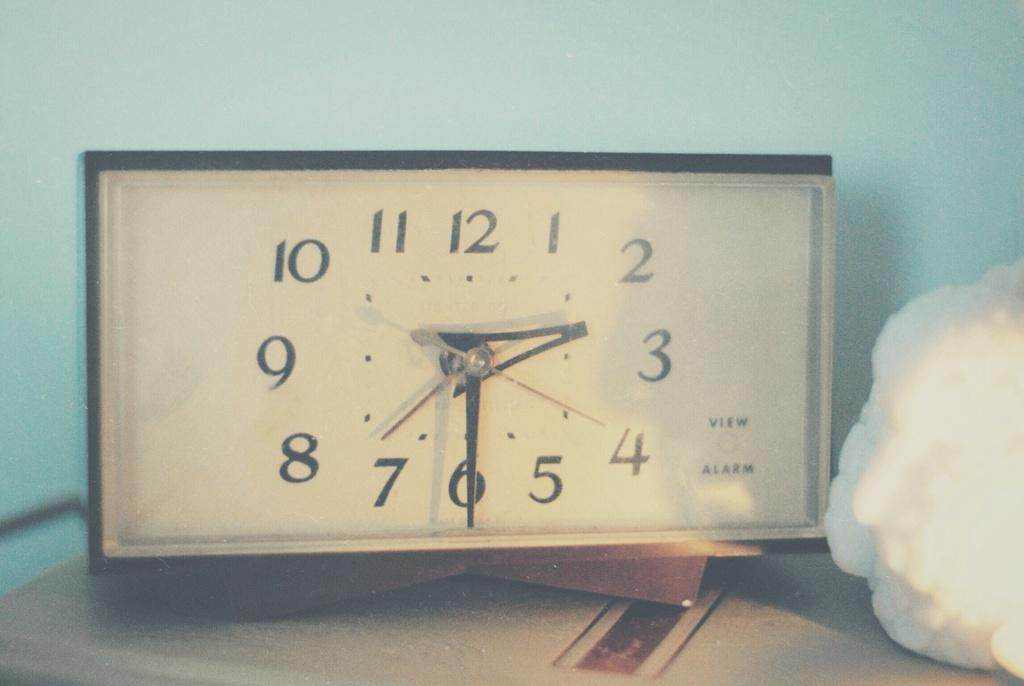<image>
Present a compact description of the photo's key features. The alarm is set for 2:30 and set on the table 